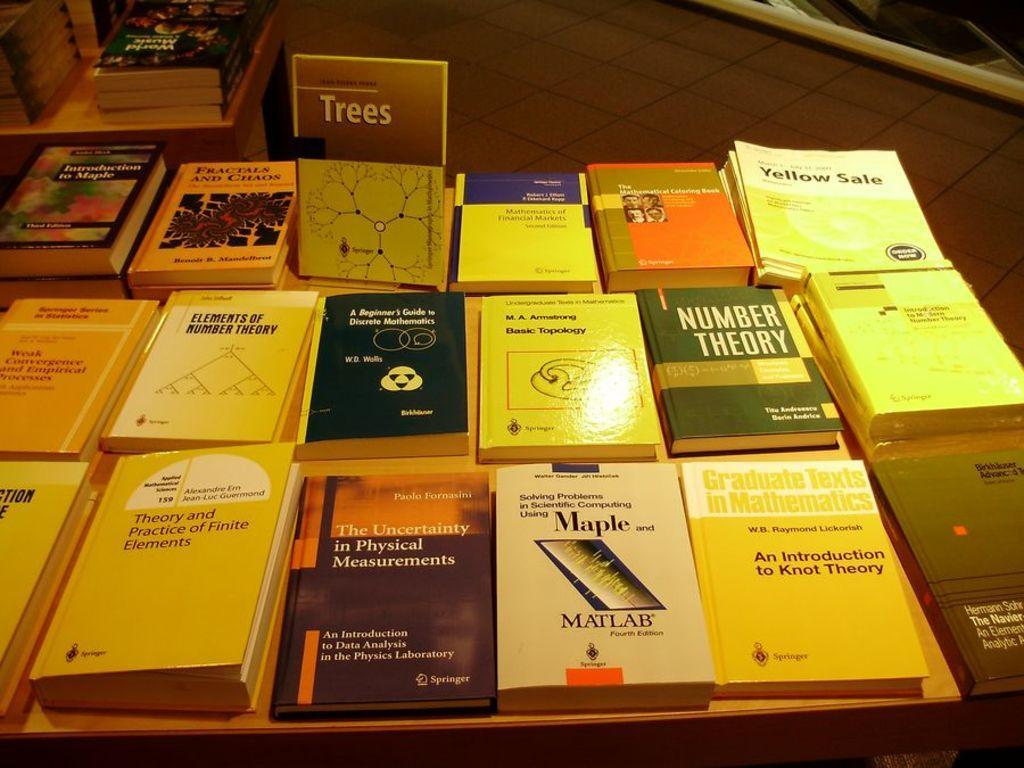In one or two sentences, can you explain what this image depicts? In this image I can see a table on which few books are placed. 